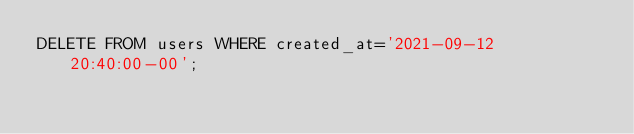<code> <loc_0><loc_0><loc_500><loc_500><_SQL_>DELETE FROM users WHERE created_at='2021-09-12 20:40:00-00';</code> 